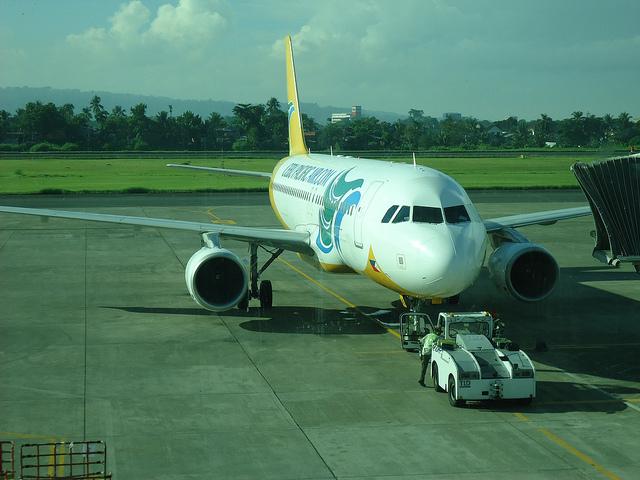How long is the plane?
Keep it brief. Long. How many planes are there?
Keep it brief. 1. Is this a cloudy day?
Concise answer only. Yes. 